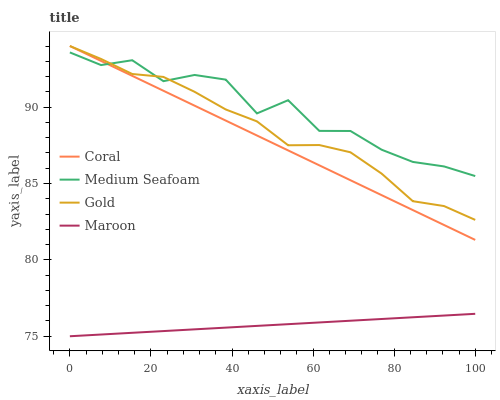Does Maroon have the minimum area under the curve?
Answer yes or no. Yes. Does Medium Seafoam have the maximum area under the curve?
Answer yes or no. Yes. Does Coral have the minimum area under the curve?
Answer yes or no. No. Does Coral have the maximum area under the curve?
Answer yes or no. No. Is Maroon the smoothest?
Answer yes or no. Yes. Is Medium Seafoam the roughest?
Answer yes or no. Yes. Is Coral the smoothest?
Answer yes or no. No. Is Coral the roughest?
Answer yes or no. No. Does Maroon have the lowest value?
Answer yes or no. Yes. Does Coral have the lowest value?
Answer yes or no. No. Does Gold have the highest value?
Answer yes or no. Yes. Does Medium Seafoam have the highest value?
Answer yes or no. No. Is Maroon less than Gold?
Answer yes or no. Yes. Is Gold greater than Maroon?
Answer yes or no. Yes. Does Coral intersect Medium Seafoam?
Answer yes or no. Yes. Is Coral less than Medium Seafoam?
Answer yes or no. No. Is Coral greater than Medium Seafoam?
Answer yes or no. No. Does Maroon intersect Gold?
Answer yes or no. No. 